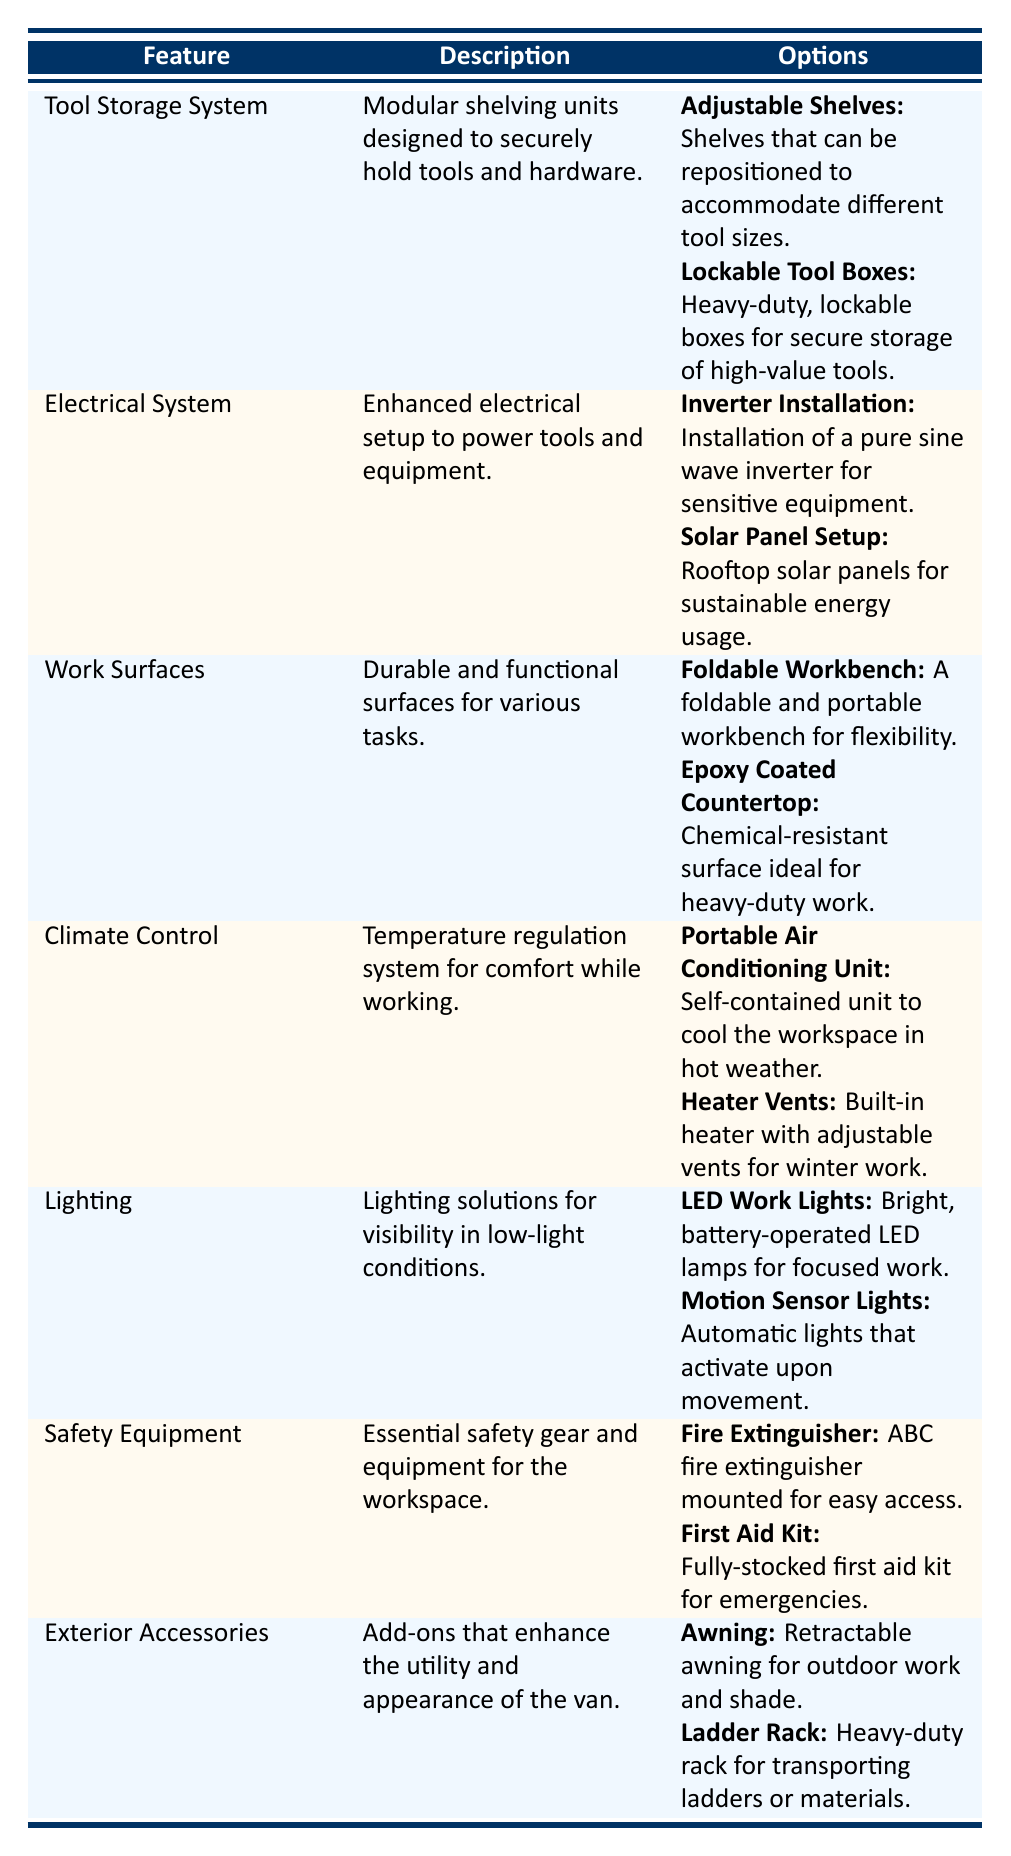What type of lighting options are available for mobile workshops? The table lists two lighting options: LED Work Lights and Motion Sensor Lights. LED Work Lights are bright, battery-operated lamps for focused work, while Motion Sensor Lights activate automatically upon movement.
Answer: LED Work Lights and Motion Sensor Lights Is there a safety feature in the customization options? Yes, the table includes a Safety Equipment feature with two options: a Fire Extinguisher and a First Aid Kit. Therefore, the answer is true.
Answer: Yes How many exterior accessory options are there? The Exterior Accessories feature has two options: Awning and Ladder Rack. Since the count of options is 2, that is the answer.
Answer: 2 What is the purpose of the Climate Control feature? The Climate Control feature aims to regulate temperature for comfort while working in the mobile workshop.
Answer: To regulate temperature for comfort Which has more options, the Electrical System or the Work Surfaces? The Electrical System has 2 options (Inverter Installation and Solar Panel Setup), while the Work Surfaces also has 2 options (Foldable Workbench and Epoxy Coated Countertop). Since both have the same number of options, the answer is that they have equal options.
Answer: Equal What is the combined number of options for Tool Storage System and Safety Equipment? The Tool Storage System has 2 options (Adjustable Shelves and Lockable Tool Boxes), and the Safety Equipment also has 2 options (Fire Extinguisher and First Aid Kit). Therefore, the combined total is 2 + 2 = 4 options.
Answer: 4 Do the Work Surfaces have any portable options? Yes, within the Work Surfaces feature, one of the options is a Foldable Workbench, which is portable. So the answer is true.
Answer: Yes Which feature provides a chemical-resistant surface? The Epoxy Coated Countertop under Work Surfaces is specifically described as a chemical-resistant surface ideal for heavy-duty work.
Answer: Epoxy Coated Countertop What can you install if you want sustainable energy for your mobile workshop? The table lists the Solar Panel Setup under the Electrical System as an option for sustainable energy usage in the mobile workshop.
Answer: Solar Panel Setup 